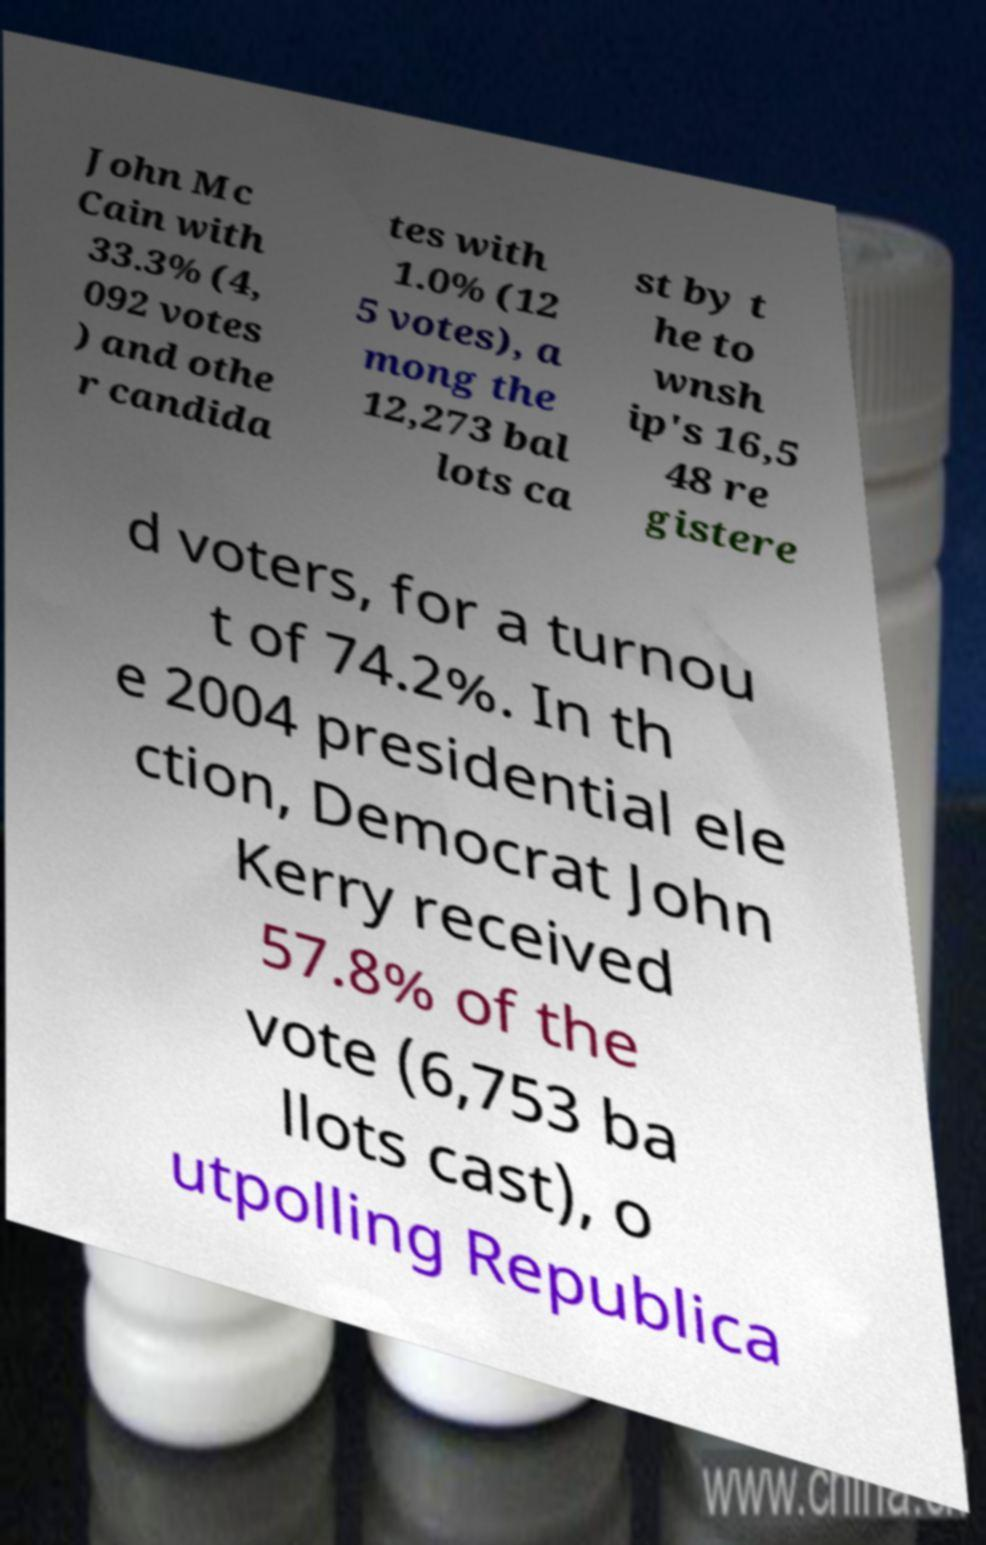Please identify and transcribe the text found in this image. John Mc Cain with 33.3% (4, 092 votes ) and othe r candida tes with 1.0% (12 5 votes), a mong the 12,273 bal lots ca st by t he to wnsh ip's 16,5 48 re gistere d voters, for a turnou t of 74.2%. In th e 2004 presidential ele ction, Democrat John Kerry received 57.8% of the vote (6,753 ba llots cast), o utpolling Republica 